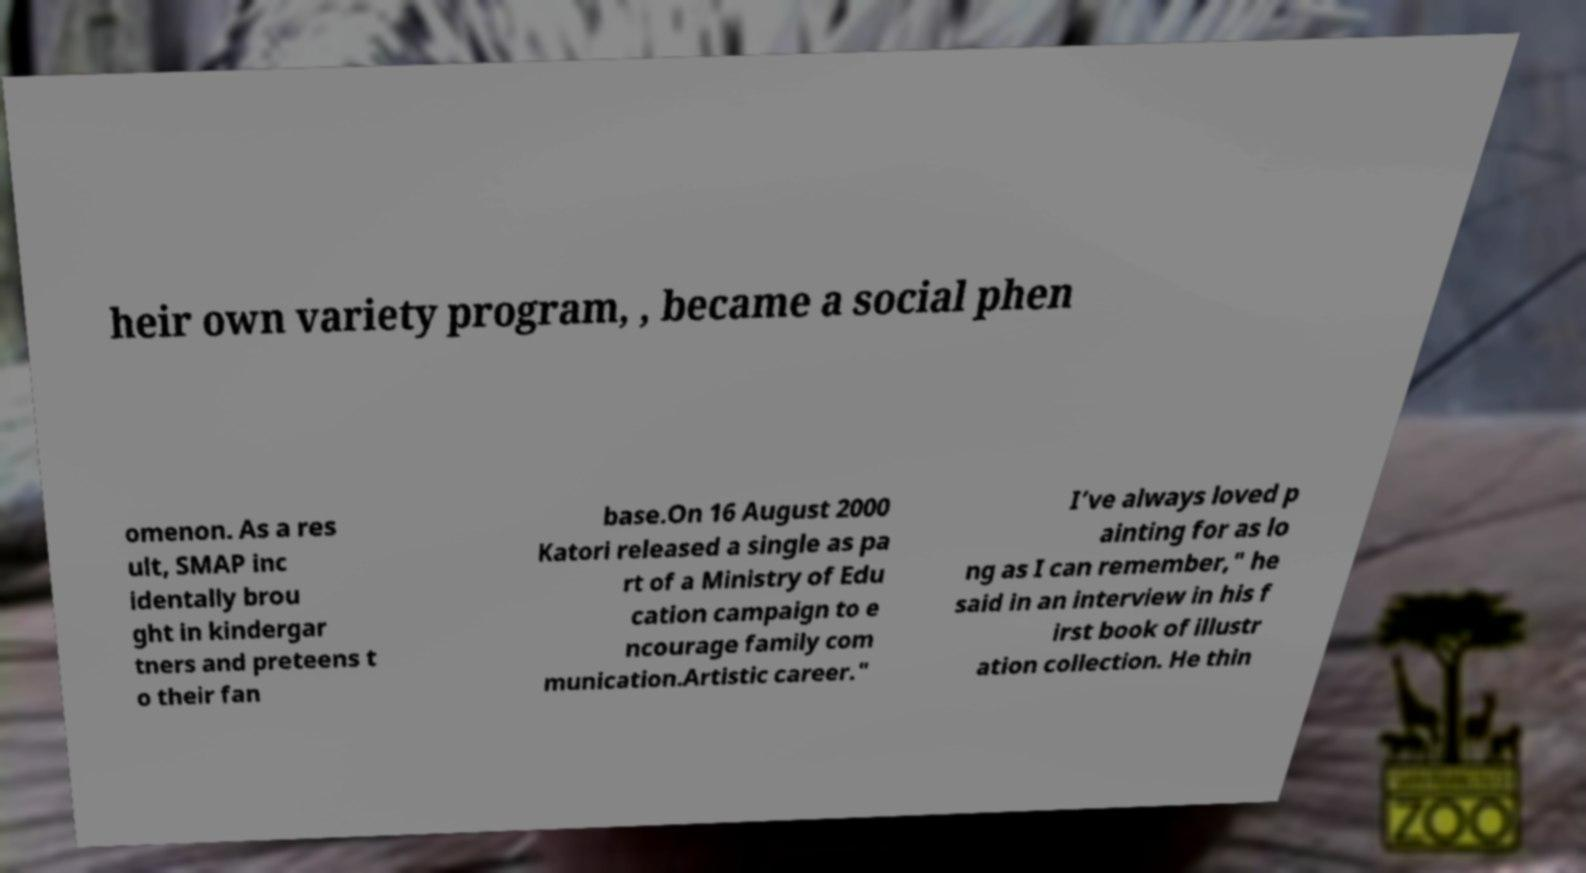Could you extract and type out the text from this image? heir own variety program, , became a social phen omenon. As a res ult, SMAP inc identally brou ght in kindergar tners and preteens t o their fan base.On 16 August 2000 Katori released a single as pa rt of a Ministry of Edu cation campaign to e ncourage family com munication.Artistic career." I’ve always loved p ainting for as lo ng as I can remember," he said in an interview in his f irst book of illustr ation collection. He thin 